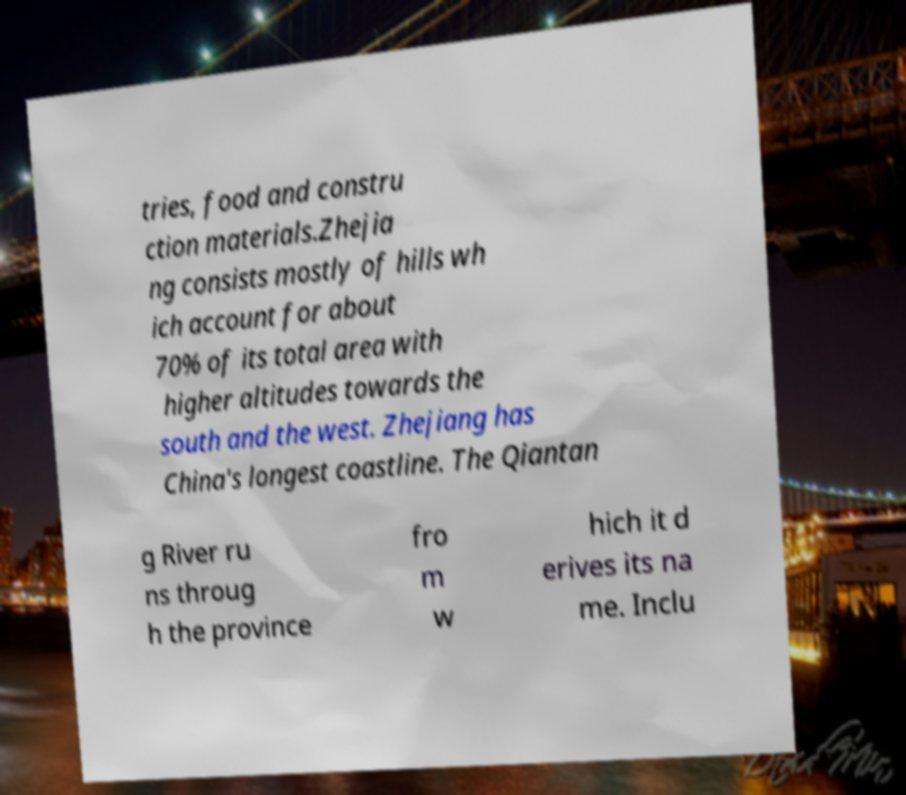For documentation purposes, I need the text within this image transcribed. Could you provide that? tries, food and constru ction materials.Zhejia ng consists mostly of hills wh ich account for about 70% of its total area with higher altitudes towards the south and the west. Zhejiang has China's longest coastline. The Qiantan g River ru ns throug h the province fro m w hich it d erives its na me. Inclu 